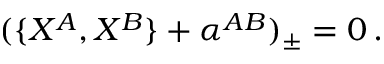Convert formula to latex. <formula><loc_0><loc_0><loc_500><loc_500>( \{ X ^ { A } , X ^ { B } \} + \alpha ^ { A B } ) _ { \pm } = 0 \, .</formula> 